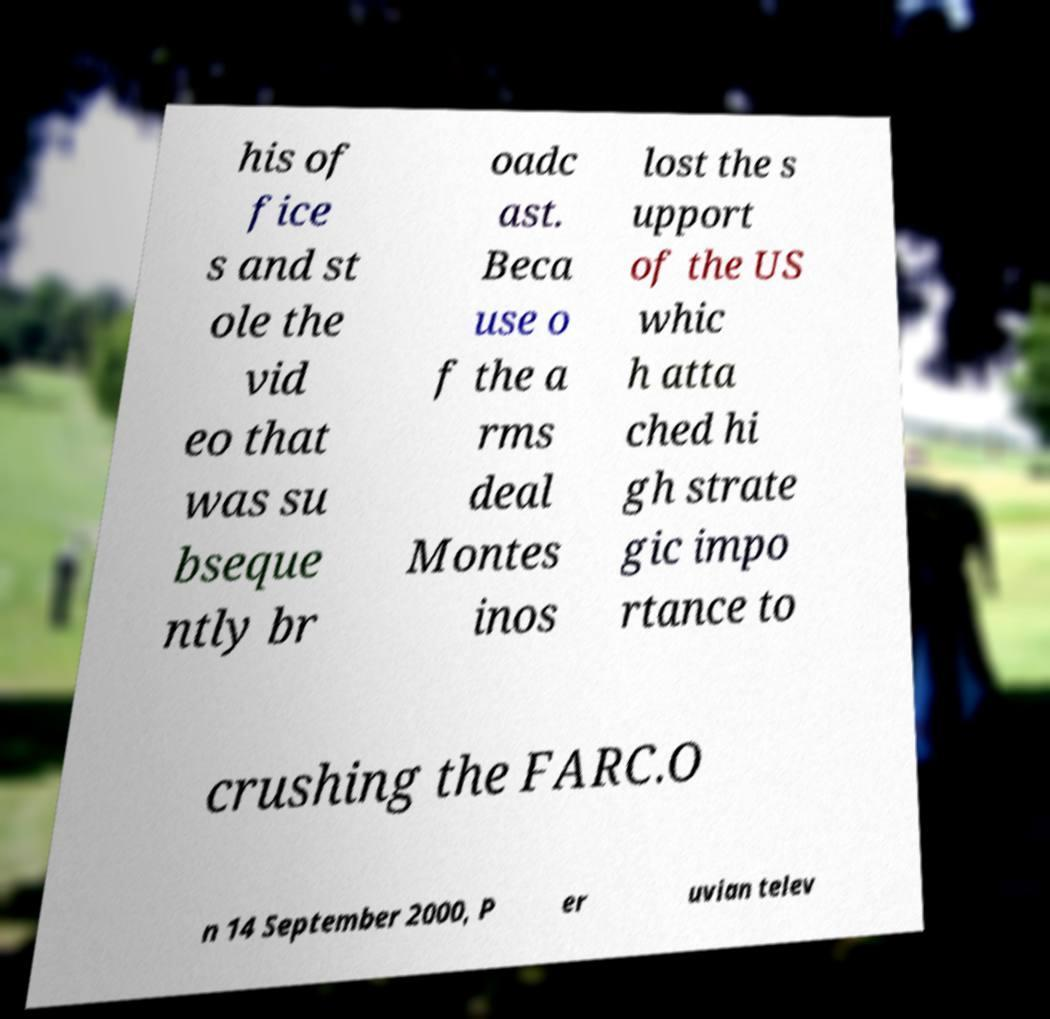Can you accurately transcribe the text from the provided image for me? his of fice s and st ole the vid eo that was su bseque ntly br oadc ast. Beca use o f the a rms deal Montes inos lost the s upport of the US whic h atta ched hi gh strate gic impo rtance to crushing the FARC.O n 14 September 2000, P er uvian telev 